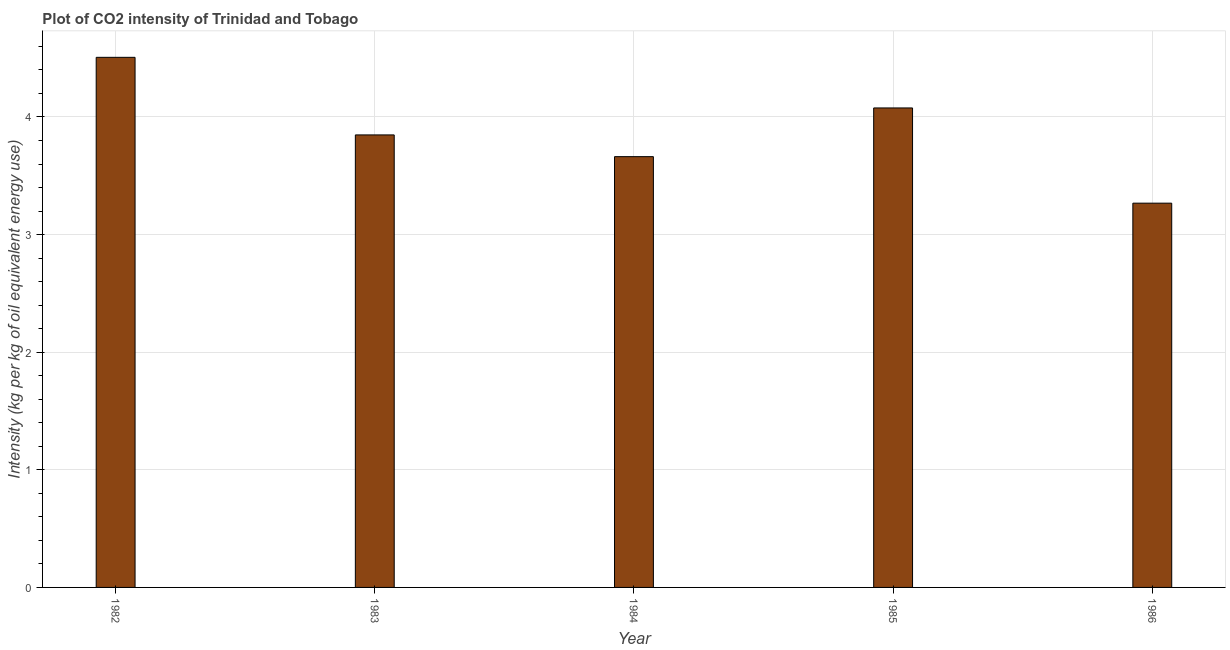Does the graph contain any zero values?
Ensure brevity in your answer.  No. Does the graph contain grids?
Offer a very short reply. Yes. What is the title of the graph?
Keep it short and to the point. Plot of CO2 intensity of Trinidad and Tobago. What is the label or title of the X-axis?
Your response must be concise. Year. What is the label or title of the Y-axis?
Provide a short and direct response. Intensity (kg per kg of oil equivalent energy use). What is the co2 intensity in 1985?
Your answer should be very brief. 4.08. Across all years, what is the maximum co2 intensity?
Offer a very short reply. 4.51. Across all years, what is the minimum co2 intensity?
Your response must be concise. 3.27. What is the sum of the co2 intensity?
Offer a very short reply. 19.36. What is the difference between the co2 intensity in 1983 and 1985?
Your response must be concise. -0.23. What is the average co2 intensity per year?
Offer a very short reply. 3.87. What is the median co2 intensity?
Give a very brief answer. 3.85. What is the ratio of the co2 intensity in 1982 to that in 1986?
Offer a very short reply. 1.38. Is the co2 intensity in 1983 less than that in 1986?
Your response must be concise. No. Is the difference between the co2 intensity in 1983 and 1984 greater than the difference between any two years?
Provide a succinct answer. No. What is the difference between the highest and the second highest co2 intensity?
Your answer should be very brief. 0.43. Is the sum of the co2 intensity in 1982 and 1985 greater than the maximum co2 intensity across all years?
Offer a very short reply. Yes. What is the difference between the highest and the lowest co2 intensity?
Give a very brief answer. 1.24. How many bars are there?
Ensure brevity in your answer.  5. Are all the bars in the graph horizontal?
Your answer should be compact. No. How many years are there in the graph?
Your answer should be very brief. 5. What is the Intensity (kg per kg of oil equivalent energy use) in 1982?
Offer a terse response. 4.51. What is the Intensity (kg per kg of oil equivalent energy use) in 1983?
Offer a very short reply. 3.85. What is the Intensity (kg per kg of oil equivalent energy use) of 1984?
Your answer should be very brief. 3.66. What is the Intensity (kg per kg of oil equivalent energy use) of 1985?
Offer a very short reply. 4.08. What is the Intensity (kg per kg of oil equivalent energy use) of 1986?
Offer a terse response. 3.27. What is the difference between the Intensity (kg per kg of oil equivalent energy use) in 1982 and 1983?
Your answer should be very brief. 0.66. What is the difference between the Intensity (kg per kg of oil equivalent energy use) in 1982 and 1984?
Keep it short and to the point. 0.84. What is the difference between the Intensity (kg per kg of oil equivalent energy use) in 1982 and 1985?
Offer a terse response. 0.43. What is the difference between the Intensity (kg per kg of oil equivalent energy use) in 1982 and 1986?
Keep it short and to the point. 1.24. What is the difference between the Intensity (kg per kg of oil equivalent energy use) in 1983 and 1984?
Provide a short and direct response. 0.18. What is the difference between the Intensity (kg per kg of oil equivalent energy use) in 1983 and 1985?
Ensure brevity in your answer.  -0.23. What is the difference between the Intensity (kg per kg of oil equivalent energy use) in 1983 and 1986?
Your response must be concise. 0.58. What is the difference between the Intensity (kg per kg of oil equivalent energy use) in 1984 and 1985?
Ensure brevity in your answer.  -0.41. What is the difference between the Intensity (kg per kg of oil equivalent energy use) in 1984 and 1986?
Provide a succinct answer. 0.4. What is the difference between the Intensity (kg per kg of oil equivalent energy use) in 1985 and 1986?
Give a very brief answer. 0.81. What is the ratio of the Intensity (kg per kg of oil equivalent energy use) in 1982 to that in 1983?
Your answer should be compact. 1.17. What is the ratio of the Intensity (kg per kg of oil equivalent energy use) in 1982 to that in 1984?
Offer a terse response. 1.23. What is the ratio of the Intensity (kg per kg of oil equivalent energy use) in 1982 to that in 1985?
Offer a very short reply. 1.11. What is the ratio of the Intensity (kg per kg of oil equivalent energy use) in 1982 to that in 1986?
Your answer should be compact. 1.38. What is the ratio of the Intensity (kg per kg of oil equivalent energy use) in 1983 to that in 1984?
Your answer should be compact. 1.05. What is the ratio of the Intensity (kg per kg of oil equivalent energy use) in 1983 to that in 1985?
Ensure brevity in your answer.  0.94. What is the ratio of the Intensity (kg per kg of oil equivalent energy use) in 1983 to that in 1986?
Provide a short and direct response. 1.18. What is the ratio of the Intensity (kg per kg of oil equivalent energy use) in 1984 to that in 1985?
Your answer should be compact. 0.9. What is the ratio of the Intensity (kg per kg of oil equivalent energy use) in 1984 to that in 1986?
Provide a succinct answer. 1.12. What is the ratio of the Intensity (kg per kg of oil equivalent energy use) in 1985 to that in 1986?
Offer a very short reply. 1.25. 